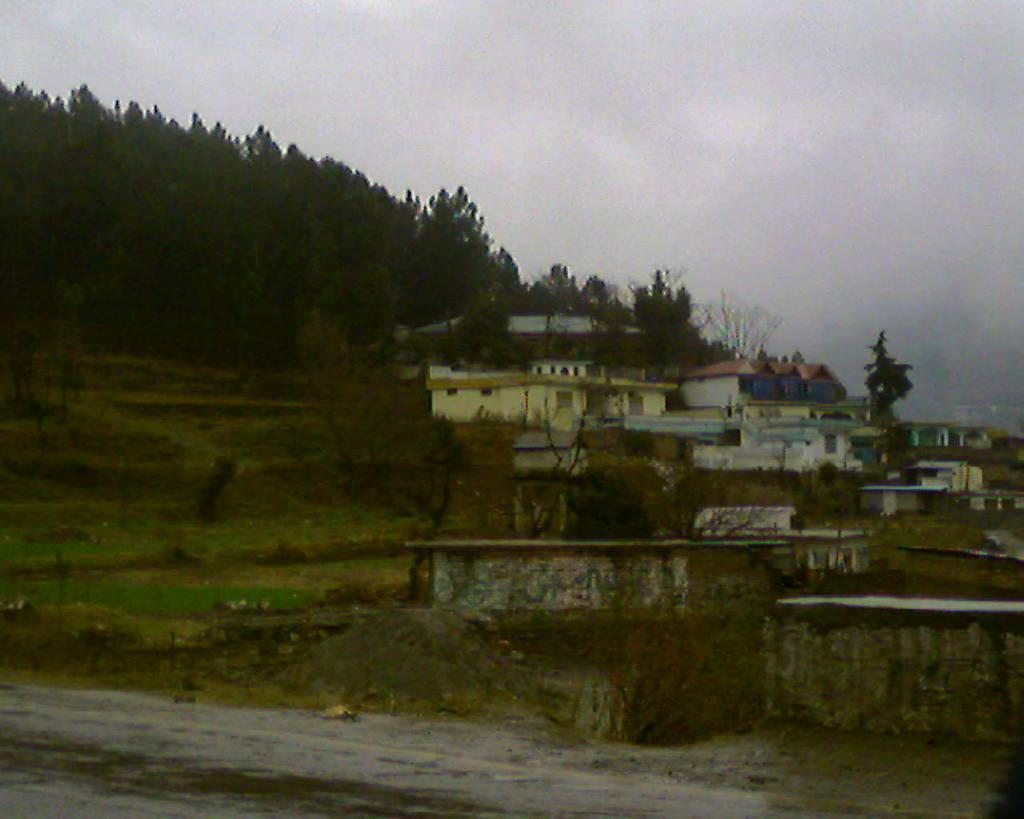What is visible at the bottom of the image? The ground is visible in the image. What can be seen in the distance in the image? There are buildings, trees, grass, and the sky visible in the background of the image. What type of noise can be heard coming from the fang in the image? There is no fang present in the image, so it's not possible to determine what, if any, noise might be heard. 